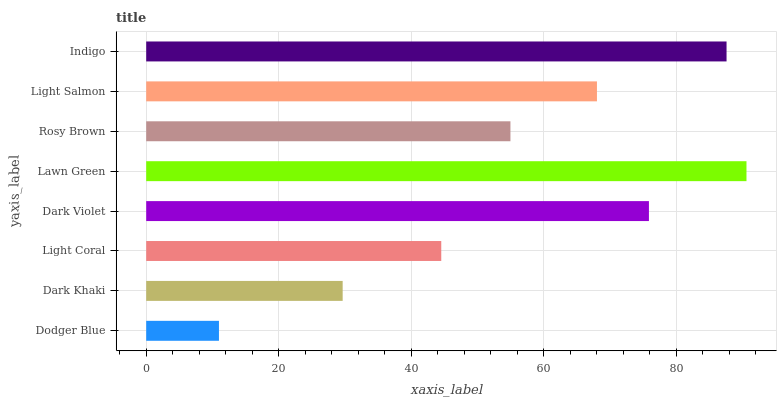Is Dodger Blue the minimum?
Answer yes or no. Yes. Is Lawn Green the maximum?
Answer yes or no. Yes. Is Dark Khaki the minimum?
Answer yes or no. No. Is Dark Khaki the maximum?
Answer yes or no. No. Is Dark Khaki greater than Dodger Blue?
Answer yes or no. Yes. Is Dodger Blue less than Dark Khaki?
Answer yes or no. Yes. Is Dodger Blue greater than Dark Khaki?
Answer yes or no. No. Is Dark Khaki less than Dodger Blue?
Answer yes or no. No. Is Light Salmon the high median?
Answer yes or no. Yes. Is Rosy Brown the low median?
Answer yes or no. Yes. Is Light Coral the high median?
Answer yes or no. No. Is Light Salmon the low median?
Answer yes or no. No. 